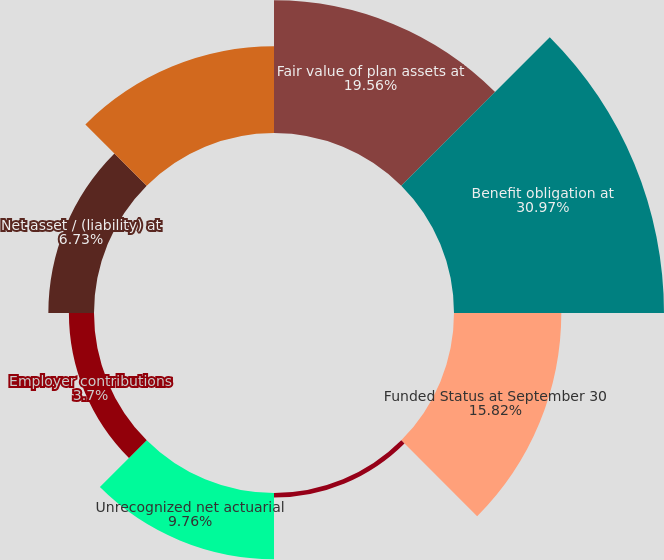<chart> <loc_0><loc_0><loc_500><loc_500><pie_chart><fcel>Fair value of plan assets at<fcel>Benefit obligation at<fcel>Funded Status at September 30<fcel>Unrecognized net prior service<fcel>Unrecognized net actuarial<fcel>Employer contributions<fcel>Net asset / (liability) at<fcel>Pension and postretirement<nl><fcel>19.56%<fcel>30.96%<fcel>15.82%<fcel>0.67%<fcel>9.76%<fcel>3.7%<fcel>6.73%<fcel>12.79%<nl></chart> 